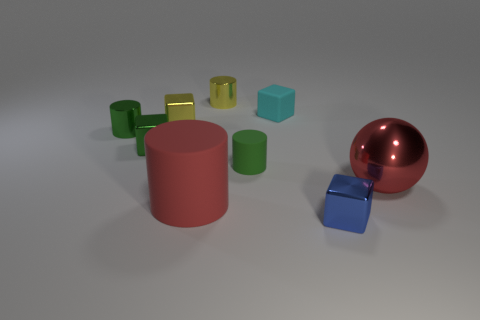Subtract all tiny green blocks. How many blocks are left? 3 Add 1 metallic objects. How many objects exist? 10 Subtract 1 cylinders. How many cylinders are left? 3 Subtract all cyan balls. How many yellow cubes are left? 1 Subtract all big red things. Subtract all small blue metallic blocks. How many objects are left? 6 Add 7 metal cylinders. How many metal cylinders are left? 9 Add 7 yellow metallic things. How many yellow metallic things exist? 9 Subtract all green cylinders. How many cylinders are left? 2 Subtract 0 blue cylinders. How many objects are left? 9 Subtract all cylinders. How many objects are left? 5 